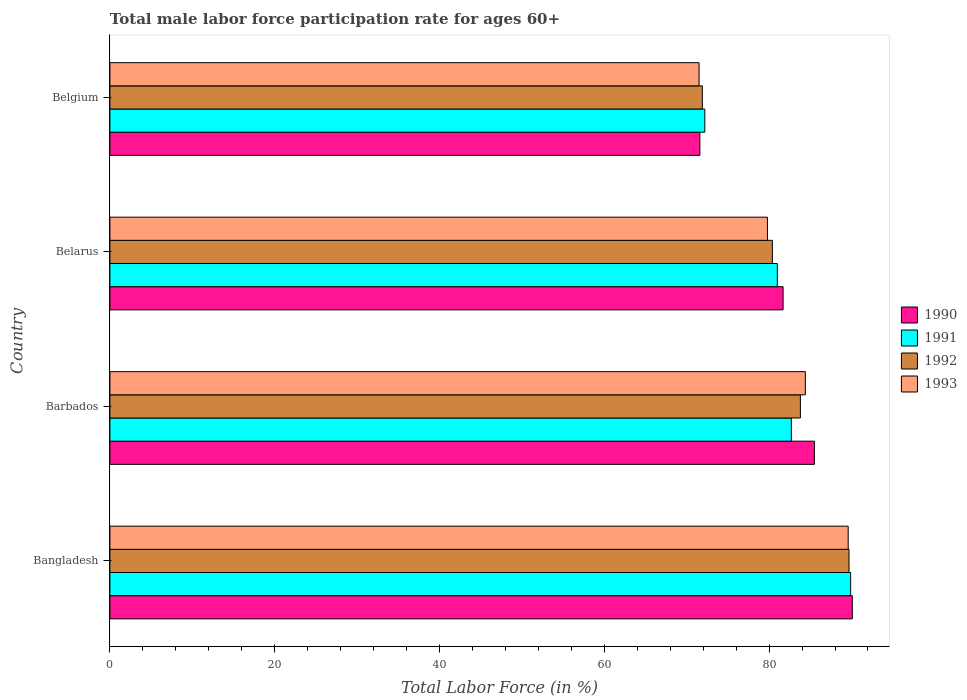How many different coloured bars are there?
Make the answer very short. 4. How many groups of bars are there?
Provide a succinct answer. 4. How many bars are there on the 4th tick from the top?
Your response must be concise. 4. How many bars are there on the 1st tick from the bottom?
Keep it short and to the point. 4. What is the label of the 4th group of bars from the top?
Keep it short and to the point. Bangladesh. What is the male labor force participation rate in 1990 in Bangladesh?
Ensure brevity in your answer.  90.1. Across all countries, what is the maximum male labor force participation rate in 1992?
Offer a very short reply. 89.7. Across all countries, what is the minimum male labor force participation rate in 1991?
Offer a very short reply. 72.2. In which country was the male labor force participation rate in 1991 minimum?
Your response must be concise. Belgium. What is the total male labor force participation rate in 1990 in the graph?
Your answer should be compact. 328.9. What is the difference between the male labor force participation rate in 1991 in Bangladesh and that in Belarus?
Your answer should be compact. 8.9. What is the difference between the male labor force participation rate in 1993 in Bangladesh and the male labor force participation rate in 1992 in Barbados?
Ensure brevity in your answer.  5.8. What is the average male labor force participation rate in 1990 per country?
Offer a very short reply. 82.22. What is the difference between the male labor force participation rate in 1993 and male labor force participation rate in 1992 in Bangladesh?
Make the answer very short. -0.1. What is the ratio of the male labor force participation rate in 1991 in Bangladesh to that in Belarus?
Make the answer very short. 1.11. What is the difference between the highest and the second highest male labor force participation rate in 1992?
Offer a very short reply. 5.9. What is the difference between the highest and the lowest male labor force participation rate in 1993?
Ensure brevity in your answer.  18.1. What does the 3rd bar from the top in Bangladesh represents?
Your response must be concise. 1991. What does the 4th bar from the bottom in Belarus represents?
Make the answer very short. 1993. Are the values on the major ticks of X-axis written in scientific E-notation?
Provide a short and direct response. No. Does the graph contain any zero values?
Your answer should be very brief. No. Does the graph contain grids?
Your response must be concise. No. Where does the legend appear in the graph?
Keep it short and to the point. Center right. How are the legend labels stacked?
Offer a very short reply. Vertical. What is the title of the graph?
Your answer should be compact. Total male labor force participation rate for ages 60+. What is the label or title of the Y-axis?
Keep it short and to the point. Country. What is the Total Labor Force (in %) of 1990 in Bangladesh?
Give a very brief answer. 90.1. What is the Total Labor Force (in %) in 1991 in Bangladesh?
Your response must be concise. 89.9. What is the Total Labor Force (in %) of 1992 in Bangladesh?
Your response must be concise. 89.7. What is the Total Labor Force (in %) of 1993 in Bangladesh?
Keep it short and to the point. 89.6. What is the Total Labor Force (in %) of 1990 in Barbados?
Keep it short and to the point. 85.5. What is the Total Labor Force (in %) in 1991 in Barbados?
Provide a short and direct response. 82.7. What is the Total Labor Force (in %) in 1992 in Barbados?
Make the answer very short. 83.8. What is the Total Labor Force (in %) of 1993 in Barbados?
Provide a short and direct response. 84.4. What is the Total Labor Force (in %) in 1990 in Belarus?
Ensure brevity in your answer.  81.7. What is the Total Labor Force (in %) of 1992 in Belarus?
Your response must be concise. 80.4. What is the Total Labor Force (in %) of 1993 in Belarus?
Your answer should be very brief. 79.8. What is the Total Labor Force (in %) in 1990 in Belgium?
Provide a succinct answer. 71.6. What is the Total Labor Force (in %) in 1991 in Belgium?
Provide a short and direct response. 72.2. What is the Total Labor Force (in %) in 1992 in Belgium?
Keep it short and to the point. 71.9. What is the Total Labor Force (in %) in 1993 in Belgium?
Keep it short and to the point. 71.5. Across all countries, what is the maximum Total Labor Force (in %) of 1990?
Provide a succinct answer. 90.1. Across all countries, what is the maximum Total Labor Force (in %) of 1991?
Provide a short and direct response. 89.9. Across all countries, what is the maximum Total Labor Force (in %) of 1992?
Give a very brief answer. 89.7. Across all countries, what is the maximum Total Labor Force (in %) of 1993?
Offer a terse response. 89.6. Across all countries, what is the minimum Total Labor Force (in %) in 1990?
Offer a very short reply. 71.6. Across all countries, what is the minimum Total Labor Force (in %) in 1991?
Provide a succinct answer. 72.2. Across all countries, what is the minimum Total Labor Force (in %) of 1992?
Ensure brevity in your answer.  71.9. Across all countries, what is the minimum Total Labor Force (in %) in 1993?
Your answer should be compact. 71.5. What is the total Total Labor Force (in %) in 1990 in the graph?
Ensure brevity in your answer.  328.9. What is the total Total Labor Force (in %) of 1991 in the graph?
Make the answer very short. 325.8. What is the total Total Labor Force (in %) in 1992 in the graph?
Your response must be concise. 325.8. What is the total Total Labor Force (in %) of 1993 in the graph?
Give a very brief answer. 325.3. What is the difference between the Total Labor Force (in %) of 1990 in Bangladesh and that in Barbados?
Give a very brief answer. 4.6. What is the difference between the Total Labor Force (in %) in 1992 in Bangladesh and that in Barbados?
Keep it short and to the point. 5.9. What is the difference between the Total Labor Force (in %) of 1990 in Bangladesh and that in Belarus?
Make the answer very short. 8.4. What is the difference between the Total Labor Force (in %) of 1992 in Bangladesh and that in Belarus?
Provide a short and direct response. 9.3. What is the difference between the Total Labor Force (in %) in 1993 in Bangladesh and that in Belarus?
Provide a short and direct response. 9.8. What is the difference between the Total Labor Force (in %) of 1991 in Bangladesh and that in Belgium?
Your response must be concise. 17.7. What is the difference between the Total Labor Force (in %) of 1992 in Bangladesh and that in Belgium?
Offer a terse response. 17.8. What is the difference between the Total Labor Force (in %) in 1990 in Barbados and that in Belarus?
Give a very brief answer. 3.8. What is the difference between the Total Labor Force (in %) in 1992 in Barbados and that in Belarus?
Keep it short and to the point. 3.4. What is the difference between the Total Labor Force (in %) of 1990 in Barbados and that in Belgium?
Give a very brief answer. 13.9. What is the difference between the Total Labor Force (in %) in 1991 in Barbados and that in Belgium?
Provide a succinct answer. 10.5. What is the difference between the Total Labor Force (in %) of 1993 in Barbados and that in Belgium?
Keep it short and to the point. 12.9. What is the difference between the Total Labor Force (in %) of 1992 in Belarus and that in Belgium?
Offer a terse response. 8.5. What is the difference between the Total Labor Force (in %) in 1993 in Belarus and that in Belgium?
Keep it short and to the point. 8.3. What is the difference between the Total Labor Force (in %) in 1990 in Bangladesh and the Total Labor Force (in %) in 1991 in Barbados?
Your answer should be compact. 7.4. What is the difference between the Total Labor Force (in %) in 1990 in Bangladesh and the Total Labor Force (in %) in 1993 in Barbados?
Your answer should be very brief. 5.7. What is the difference between the Total Labor Force (in %) in 1992 in Bangladesh and the Total Labor Force (in %) in 1993 in Barbados?
Offer a terse response. 5.3. What is the difference between the Total Labor Force (in %) of 1990 in Bangladesh and the Total Labor Force (in %) of 1992 in Belarus?
Your response must be concise. 9.7. What is the difference between the Total Labor Force (in %) in 1991 in Bangladesh and the Total Labor Force (in %) in 1993 in Belarus?
Provide a short and direct response. 10.1. What is the difference between the Total Labor Force (in %) of 1990 in Bangladesh and the Total Labor Force (in %) of 1991 in Belgium?
Give a very brief answer. 17.9. What is the difference between the Total Labor Force (in %) in 1990 in Bangladesh and the Total Labor Force (in %) in 1992 in Belgium?
Keep it short and to the point. 18.2. What is the difference between the Total Labor Force (in %) in 1991 in Bangladesh and the Total Labor Force (in %) in 1993 in Belgium?
Give a very brief answer. 18.4. What is the difference between the Total Labor Force (in %) of 1992 in Bangladesh and the Total Labor Force (in %) of 1993 in Belgium?
Your answer should be compact. 18.2. What is the difference between the Total Labor Force (in %) in 1990 in Barbados and the Total Labor Force (in %) in 1993 in Belarus?
Make the answer very short. 5.7. What is the difference between the Total Labor Force (in %) in 1991 in Barbados and the Total Labor Force (in %) in 1993 in Belarus?
Your answer should be compact. 2.9. What is the difference between the Total Labor Force (in %) in 1992 in Barbados and the Total Labor Force (in %) in 1993 in Belarus?
Your answer should be very brief. 4. What is the difference between the Total Labor Force (in %) of 1990 in Barbados and the Total Labor Force (in %) of 1991 in Belgium?
Make the answer very short. 13.3. What is the difference between the Total Labor Force (in %) of 1991 in Barbados and the Total Labor Force (in %) of 1992 in Belgium?
Provide a succinct answer. 10.8. What is the difference between the Total Labor Force (in %) of 1992 in Barbados and the Total Labor Force (in %) of 1993 in Belgium?
Your response must be concise. 12.3. What is the difference between the Total Labor Force (in %) in 1990 in Belarus and the Total Labor Force (in %) in 1992 in Belgium?
Give a very brief answer. 9.8. What is the difference between the Total Labor Force (in %) in 1990 in Belarus and the Total Labor Force (in %) in 1993 in Belgium?
Provide a short and direct response. 10.2. What is the difference between the Total Labor Force (in %) in 1991 in Belarus and the Total Labor Force (in %) in 1992 in Belgium?
Provide a succinct answer. 9.1. What is the average Total Labor Force (in %) in 1990 per country?
Give a very brief answer. 82.22. What is the average Total Labor Force (in %) of 1991 per country?
Ensure brevity in your answer.  81.45. What is the average Total Labor Force (in %) of 1992 per country?
Ensure brevity in your answer.  81.45. What is the average Total Labor Force (in %) of 1993 per country?
Your response must be concise. 81.33. What is the difference between the Total Labor Force (in %) in 1991 and Total Labor Force (in %) in 1992 in Bangladesh?
Make the answer very short. 0.2. What is the difference between the Total Labor Force (in %) of 1991 and Total Labor Force (in %) of 1993 in Bangladesh?
Provide a succinct answer. 0.3. What is the difference between the Total Labor Force (in %) of 1992 and Total Labor Force (in %) of 1993 in Bangladesh?
Keep it short and to the point. 0.1. What is the difference between the Total Labor Force (in %) of 1990 and Total Labor Force (in %) of 1991 in Barbados?
Your answer should be compact. 2.8. What is the difference between the Total Labor Force (in %) in 1990 and Total Labor Force (in %) in 1992 in Barbados?
Your response must be concise. 1.7. What is the difference between the Total Labor Force (in %) in 1991 and Total Labor Force (in %) in 1992 in Barbados?
Your answer should be very brief. -1.1. What is the difference between the Total Labor Force (in %) of 1991 and Total Labor Force (in %) of 1993 in Barbados?
Offer a very short reply. -1.7. What is the difference between the Total Labor Force (in %) of 1990 and Total Labor Force (in %) of 1992 in Belarus?
Ensure brevity in your answer.  1.3. What is the difference between the Total Labor Force (in %) in 1990 and Total Labor Force (in %) in 1993 in Belarus?
Make the answer very short. 1.9. What is the difference between the Total Labor Force (in %) of 1991 and Total Labor Force (in %) of 1993 in Belarus?
Offer a terse response. 1.2. What is the difference between the Total Labor Force (in %) of 1990 and Total Labor Force (in %) of 1991 in Belgium?
Keep it short and to the point. -0.6. What is the difference between the Total Labor Force (in %) of 1990 and Total Labor Force (in %) of 1992 in Belgium?
Give a very brief answer. -0.3. What is the difference between the Total Labor Force (in %) in 1991 and Total Labor Force (in %) in 1993 in Belgium?
Offer a very short reply. 0.7. What is the ratio of the Total Labor Force (in %) in 1990 in Bangladesh to that in Barbados?
Your answer should be very brief. 1.05. What is the ratio of the Total Labor Force (in %) of 1991 in Bangladesh to that in Barbados?
Your answer should be very brief. 1.09. What is the ratio of the Total Labor Force (in %) in 1992 in Bangladesh to that in Barbados?
Keep it short and to the point. 1.07. What is the ratio of the Total Labor Force (in %) in 1993 in Bangladesh to that in Barbados?
Make the answer very short. 1.06. What is the ratio of the Total Labor Force (in %) in 1990 in Bangladesh to that in Belarus?
Your response must be concise. 1.1. What is the ratio of the Total Labor Force (in %) of 1991 in Bangladesh to that in Belarus?
Offer a terse response. 1.11. What is the ratio of the Total Labor Force (in %) in 1992 in Bangladesh to that in Belarus?
Offer a terse response. 1.12. What is the ratio of the Total Labor Force (in %) of 1993 in Bangladesh to that in Belarus?
Ensure brevity in your answer.  1.12. What is the ratio of the Total Labor Force (in %) in 1990 in Bangladesh to that in Belgium?
Your response must be concise. 1.26. What is the ratio of the Total Labor Force (in %) in 1991 in Bangladesh to that in Belgium?
Give a very brief answer. 1.25. What is the ratio of the Total Labor Force (in %) in 1992 in Bangladesh to that in Belgium?
Give a very brief answer. 1.25. What is the ratio of the Total Labor Force (in %) in 1993 in Bangladesh to that in Belgium?
Your answer should be very brief. 1.25. What is the ratio of the Total Labor Force (in %) in 1990 in Barbados to that in Belarus?
Offer a very short reply. 1.05. What is the ratio of the Total Labor Force (in %) of 1991 in Barbados to that in Belarus?
Ensure brevity in your answer.  1.02. What is the ratio of the Total Labor Force (in %) of 1992 in Barbados to that in Belarus?
Make the answer very short. 1.04. What is the ratio of the Total Labor Force (in %) of 1993 in Barbados to that in Belarus?
Your response must be concise. 1.06. What is the ratio of the Total Labor Force (in %) in 1990 in Barbados to that in Belgium?
Make the answer very short. 1.19. What is the ratio of the Total Labor Force (in %) in 1991 in Barbados to that in Belgium?
Your answer should be compact. 1.15. What is the ratio of the Total Labor Force (in %) of 1992 in Barbados to that in Belgium?
Offer a terse response. 1.17. What is the ratio of the Total Labor Force (in %) in 1993 in Barbados to that in Belgium?
Your answer should be compact. 1.18. What is the ratio of the Total Labor Force (in %) in 1990 in Belarus to that in Belgium?
Offer a terse response. 1.14. What is the ratio of the Total Labor Force (in %) in 1991 in Belarus to that in Belgium?
Provide a succinct answer. 1.12. What is the ratio of the Total Labor Force (in %) in 1992 in Belarus to that in Belgium?
Your response must be concise. 1.12. What is the ratio of the Total Labor Force (in %) of 1993 in Belarus to that in Belgium?
Keep it short and to the point. 1.12. What is the difference between the highest and the second highest Total Labor Force (in %) in 1990?
Provide a short and direct response. 4.6. What is the difference between the highest and the second highest Total Labor Force (in %) of 1991?
Offer a terse response. 7.2. What is the difference between the highest and the second highest Total Labor Force (in %) of 1992?
Offer a very short reply. 5.9. What is the difference between the highest and the second highest Total Labor Force (in %) of 1993?
Make the answer very short. 5.2. What is the difference between the highest and the lowest Total Labor Force (in %) of 1991?
Give a very brief answer. 17.7. What is the difference between the highest and the lowest Total Labor Force (in %) in 1992?
Keep it short and to the point. 17.8. 